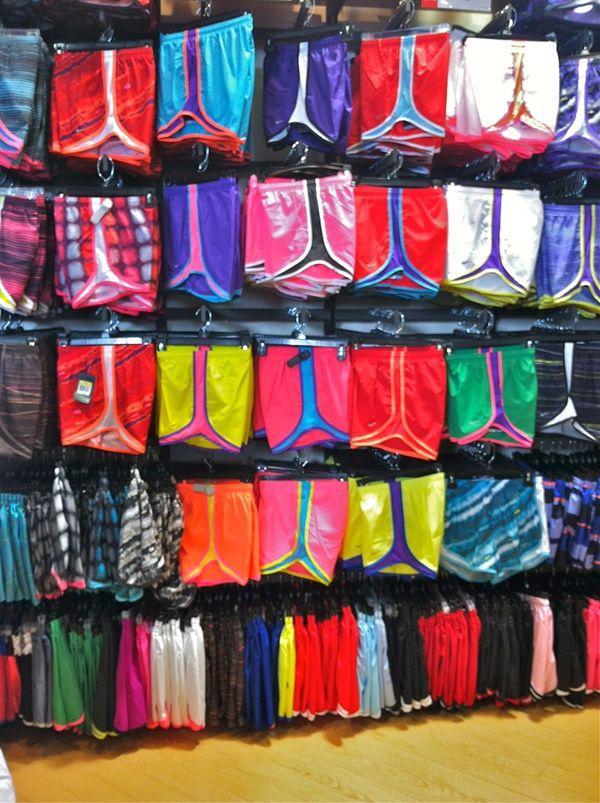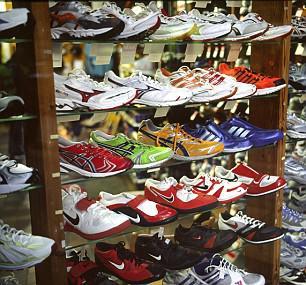The first image is the image on the left, the second image is the image on the right. Examine the images to the left and right. Is the description "Shoes are stacked into cubbies in the image on the left." accurate? Answer yes or no. No. 